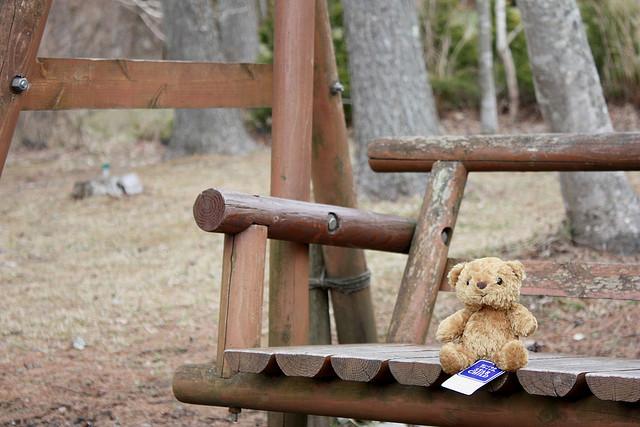Can the bench swing back and forth?
Concise answer only. Yes. What is the bench made out of?
Answer briefly. Wood. Is there a teddy bear in this picture?
Write a very short answer. Yes. 